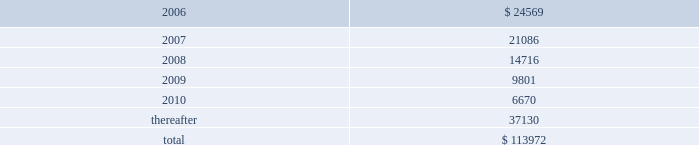Packaging corporation of america notes to consolidated financial statements ( continued ) december 31 , 2005 9 .
Shareholders 2019 equity ( continued ) stockholder received proceeds , net of the underwriting discount , of $ 20.69 per share .
The company did not sell any shares in , or receive any proceeds from , the secondary offering .
Concurrent with the closing of the secondary offering on december 21 , 2005 , the company entered into a common stock repurchase agreement with pca holdings llc .
Pursuant to the repurchase agreement , the company purchased 4500000 shares of common stock directly from pca holdings llc at the initial price to the public net of the underwriting discount or $ 20.69 per share , the same net price per share received by pca holdings llc in the secondary offering .
These shares were retired on december 21 , 2005 .
10 .
Commitments and contingencies capital commitments the company had authorized capital expenditures of approximately $ 33.1 million and $ 55.2 million as of december 31 , 2005 and 2004 , respectively , in connection with the expansion and replacement of existing facilities and equipment .
Operating leases pca leases space for certain of its facilities and cutting rights to approximately 108000 acres of timberland under long-term leases .
The company also leases equipment , primarily vehicles and rolling stock , and other assets under long-term leases of a duration generally of three years .
The minimum lease payments under non-cancelable operating leases with lease terms in excess of one year are as follows : ( in thousands ) .
Capital lease obligations were not significant to the accompanying financial statements .
Total lease expense , including base rent on all leases and executory costs , such as insurance , taxes , and maintenance , for the years ended december 31 , 2005 , 2004 and 2003 was $ 35.8 million , $ 33.0 million and $ 31.6 million , respectively .
These costs are included in cost of goods sold and selling and administrative expenses. .
Pursuant to the repurchase agreement , what was the total purchase price of the 4500000 shares of common stock directly from pca holdings llc? 
Computations: (4500000 * 20.69)
Answer: 93105000.0. Packaging corporation of america notes to consolidated financial statements ( continued ) december 31 , 2005 9 .
Shareholders 2019 equity ( continued ) stockholder received proceeds , net of the underwriting discount , of $ 20.69 per share .
The company did not sell any shares in , or receive any proceeds from , the secondary offering .
Concurrent with the closing of the secondary offering on december 21 , 2005 , the company entered into a common stock repurchase agreement with pca holdings llc .
Pursuant to the repurchase agreement , the company purchased 4500000 shares of common stock directly from pca holdings llc at the initial price to the public net of the underwriting discount or $ 20.69 per share , the same net price per share received by pca holdings llc in the secondary offering .
These shares were retired on december 21 , 2005 .
10 .
Commitments and contingencies capital commitments the company had authorized capital expenditures of approximately $ 33.1 million and $ 55.2 million as of december 31 , 2005 and 2004 , respectively , in connection with the expansion and replacement of existing facilities and equipment .
Operating leases pca leases space for certain of its facilities and cutting rights to approximately 108000 acres of timberland under long-term leases .
The company also leases equipment , primarily vehicles and rolling stock , and other assets under long-term leases of a duration generally of three years .
The minimum lease payments under non-cancelable operating leases with lease terms in excess of one year are as follows : ( in thousands ) .
Capital lease obligations were not significant to the accompanying financial statements .
Total lease expense , including base rent on all leases and executory costs , such as insurance , taxes , and maintenance , for the years ended december 31 , 2005 , 2004 and 2003 was $ 35.8 million , $ 33.0 million and $ 31.6 million , respectively .
These costs are included in cost of goods sold and selling and administrative expenses. .
What was the percentage change in total lease expense , including base rent on all leases and executory costs , such as insurance , taxes , and maintenance from 2003 to 2004? 
Computations: ((33.0 - 31.6) / 31.6)
Answer: 0.0443. Packaging corporation of america notes to consolidated financial statements ( continued ) december 31 , 2005 9 .
Shareholders 2019 equity ( continued ) stockholder received proceeds , net of the underwriting discount , of $ 20.69 per share .
The company did not sell any shares in , or receive any proceeds from , the secondary offering .
Concurrent with the closing of the secondary offering on december 21 , 2005 , the company entered into a common stock repurchase agreement with pca holdings llc .
Pursuant to the repurchase agreement , the company purchased 4500000 shares of common stock directly from pca holdings llc at the initial price to the public net of the underwriting discount or $ 20.69 per share , the same net price per share received by pca holdings llc in the secondary offering .
These shares were retired on december 21 , 2005 .
10 .
Commitments and contingencies capital commitments the company had authorized capital expenditures of approximately $ 33.1 million and $ 55.2 million as of december 31 , 2005 and 2004 , respectively , in connection with the expansion and replacement of existing facilities and equipment .
Operating leases pca leases space for certain of its facilities and cutting rights to approximately 108000 acres of timberland under long-term leases .
The company also leases equipment , primarily vehicles and rolling stock , and other assets under long-term leases of a duration generally of three years .
The minimum lease payments under non-cancelable operating leases with lease terms in excess of one year are as follows : ( in thousands ) .
Capital lease obligations were not significant to the accompanying financial statements .
Total lease expense , including base rent on all leases and executory costs , such as insurance , taxes , and maintenance , for the years ended december 31 , 2005 , 2004 and 2003 was $ 35.8 million , $ 33.0 million and $ 31.6 million , respectively .
These costs are included in cost of goods sold and selling and administrative expenses. .
What was total lease expense , including base rent on all leases and executory costs , for the years ended december 31 , 2005 and 2004 , in millions? 
Computations: (35.8 + 33.0)
Answer: 68.8. 